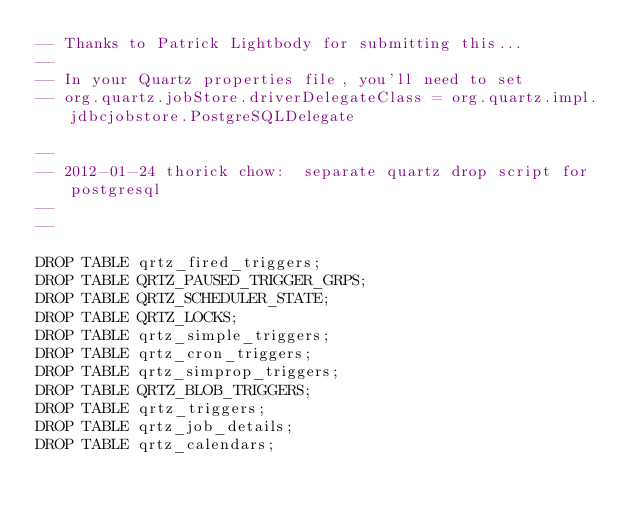Convert code to text. <code><loc_0><loc_0><loc_500><loc_500><_SQL_>-- Thanks to Patrick Lightbody for submitting this...
--
-- In your Quartz properties file, you'll need to set
-- org.quartz.jobStore.driverDelegateClass = org.quartz.impl.jdbcjobstore.PostgreSQLDelegate

--
-- 2012-01-24 thorick chow:  separate quartz drop script for postgresql
--
--

DROP TABLE qrtz_fired_triggers;
DROP TABLE QRTZ_PAUSED_TRIGGER_GRPS;
DROP TABLE QRTZ_SCHEDULER_STATE;
DROP TABLE QRTZ_LOCKS;
DROP TABLE qrtz_simple_triggers;
DROP TABLE qrtz_cron_triggers;
DROP TABLE qrtz_simprop_triggers;
DROP TABLE QRTZ_BLOB_TRIGGERS;
DROP TABLE qrtz_triggers;
DROP TABLE qrtz_job_details;
DROP TABLE qrtz_calendars;</code> 